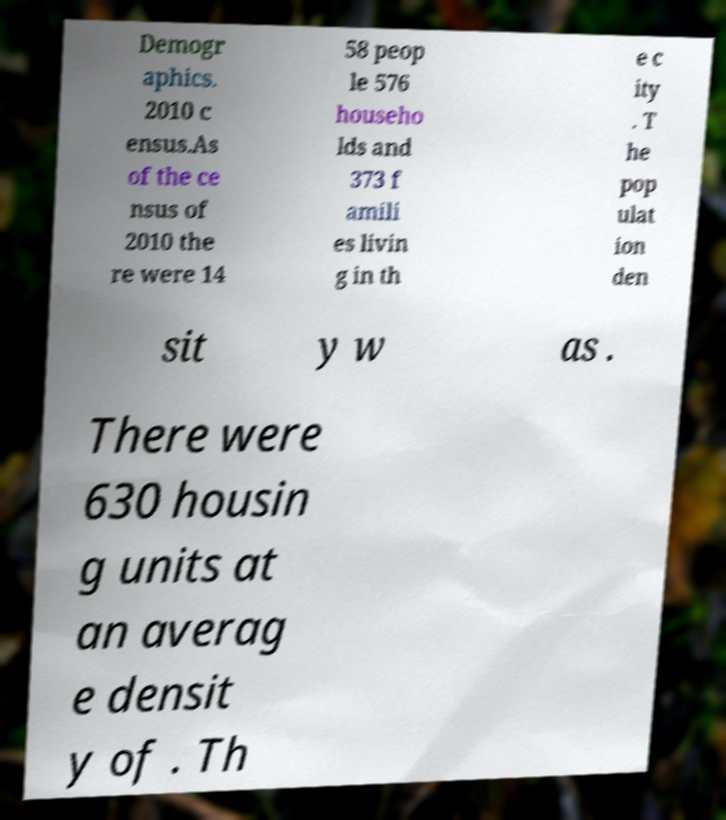There's text embedded in this image that I need extracted. Can you transcribe it verbatim? Demogr aphics. 2010 c ensus.As of the ce nsus of 2010 the re were 14 58 peop le 576 househo lds and 373 f amili es livin g in th e c ity . T he pop ulat ion den sit y w as . There were 630 housin g units at an averag e densit y of . Th 